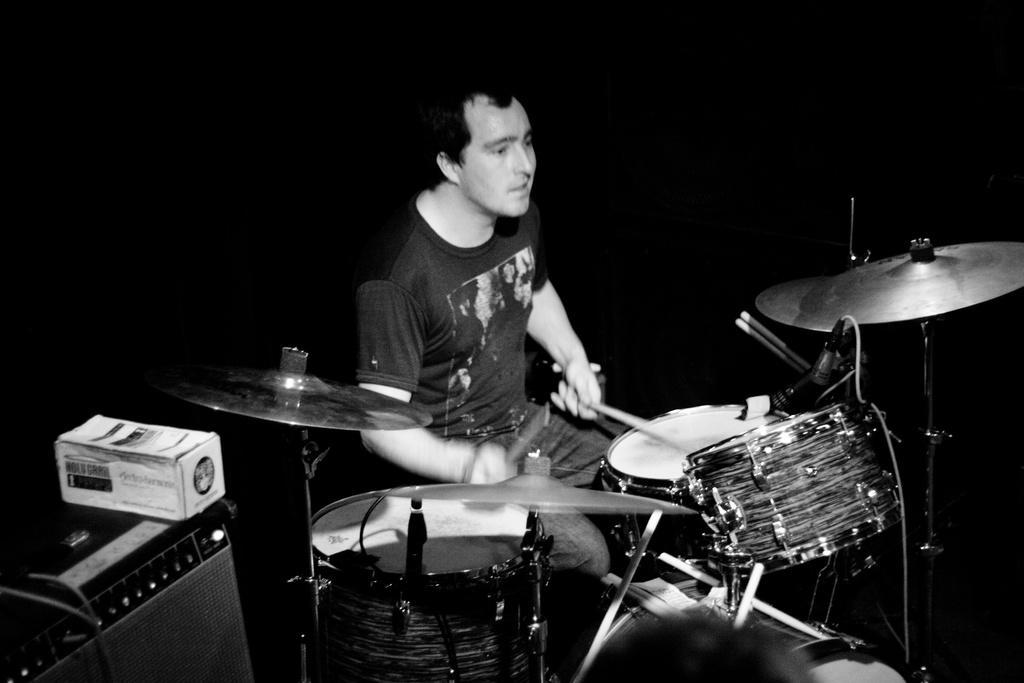Describe this image in one or two sentences. This is a black and white picture. In the center of the picture there is a person playing drums. On the left there is a speaker and a box. The background is dark. 